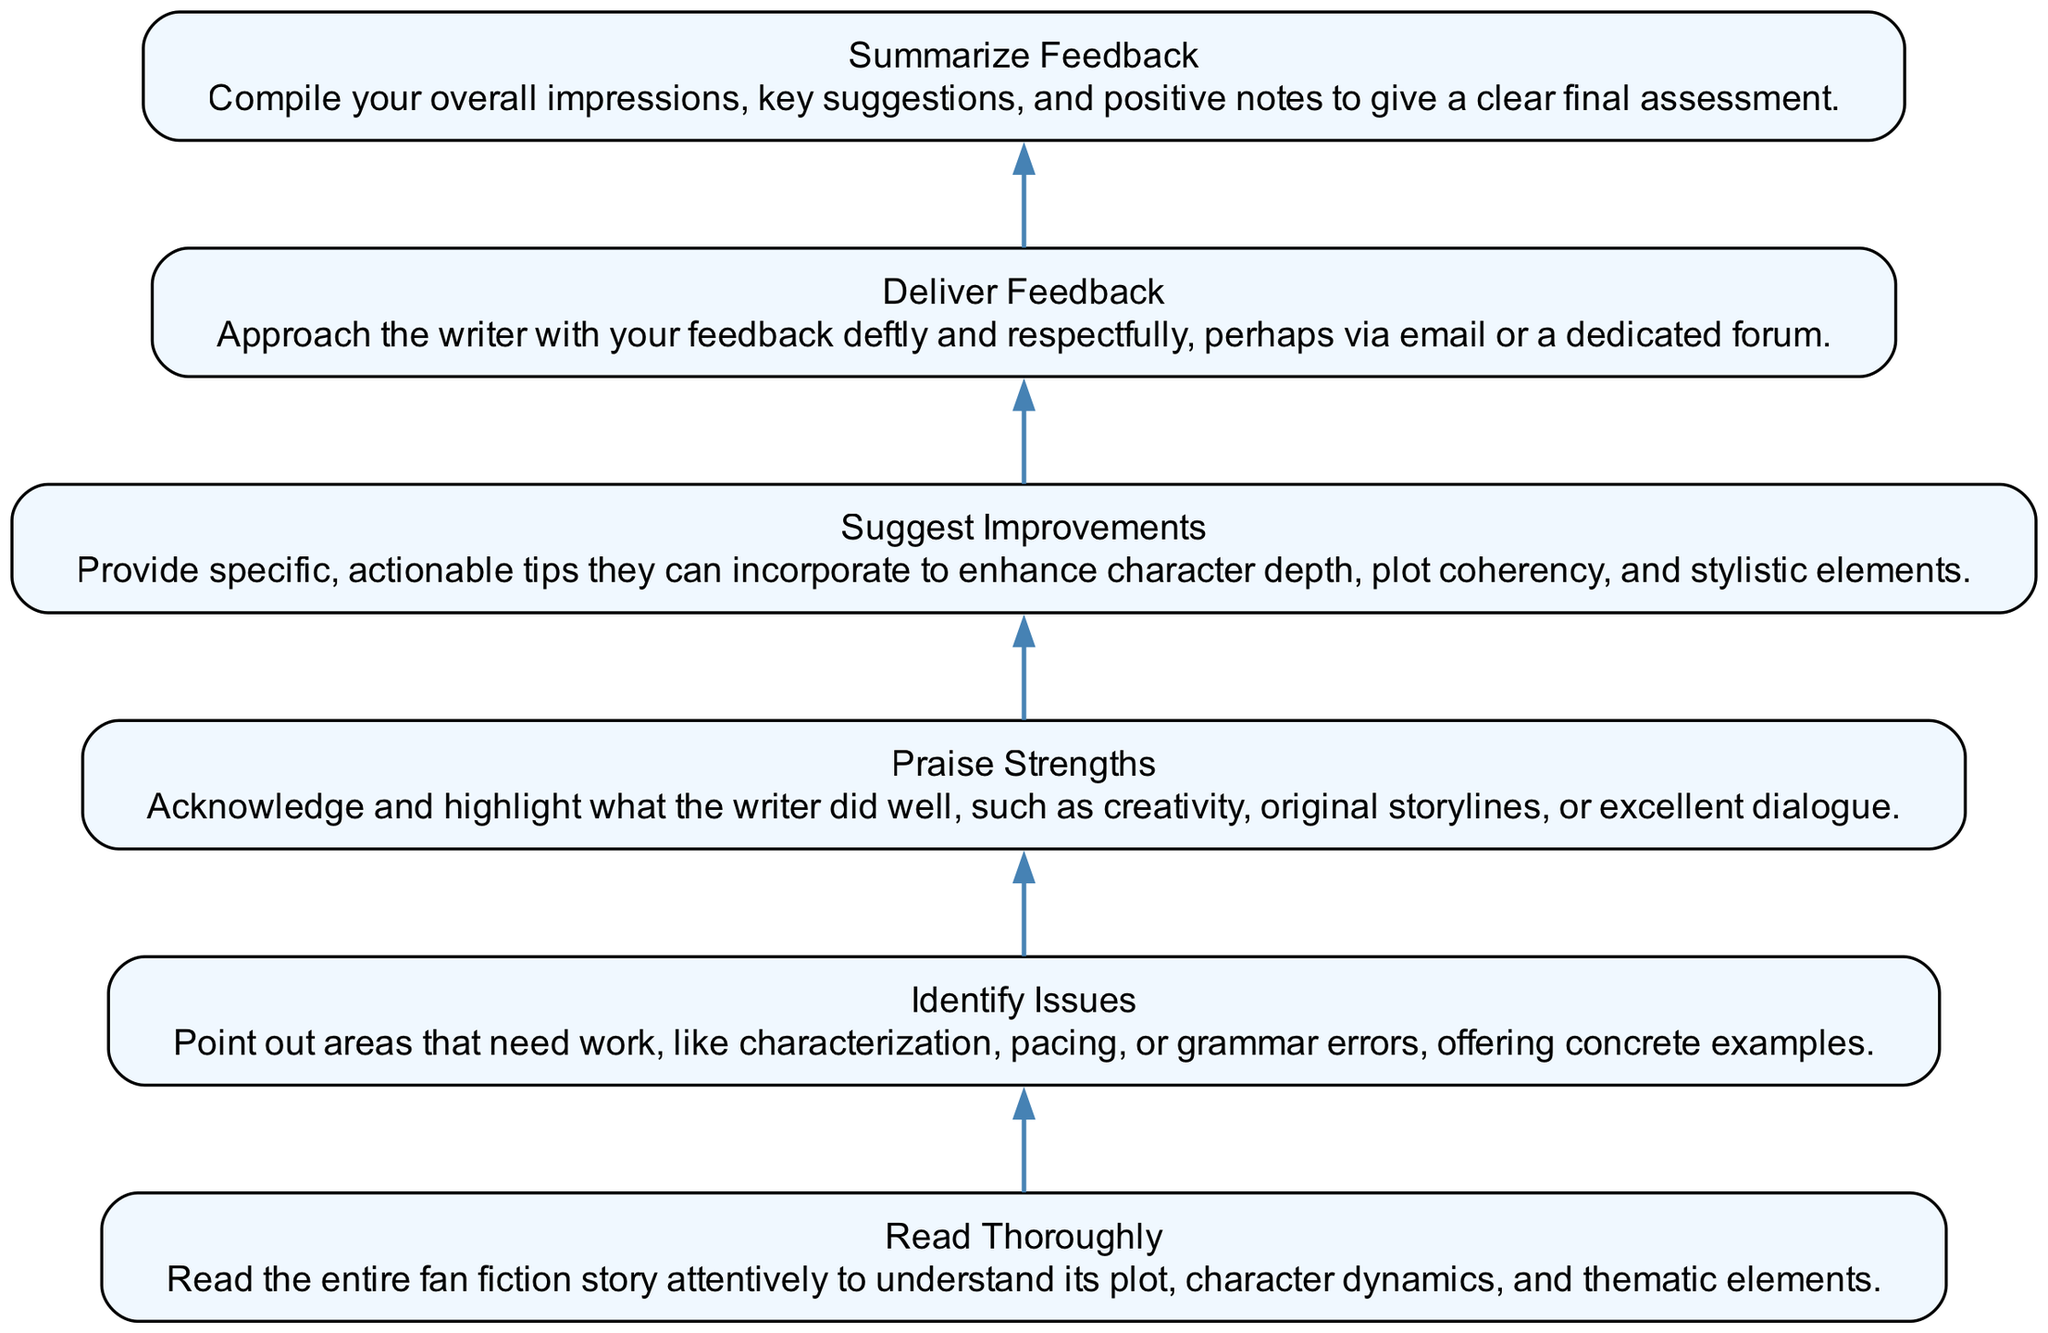What is the first step in the flowchart? The flowchart starts with the "Read Thoroughly" step, which instructs readers to engage with the entire text.
Answer: Read Thoroughly How many total steps are present in the flowchart? The diagram contains a total of six distinct steps related to constructive criticism on fan fiction stories.
Answer: Six Which step comes immediately after "Identify Issues"? The next step after "Identify Issues" is "Praise Strengths." This follows the identification of issues and leads to recognizing the positive aspects of the story.
Answer: Praise Strengths What is the last step in the feedback process? The final step of the process is "Summarize Feedback," which allows for a final assessment that includes key suggestions and positive notes.
Answer: Summarize Feedback How many nodes have "next" connections in the diagram? Out of the six steps, five of them have "next" connections that guide the flow of the feedback process, except for the last step, "Summarize Feedback."
Answer: Five Why is "Suggest Improvements" positioned before "Deliver Feedback"? "Suggest Improvements" logically precedes "Deliver Feedback" because actionable tips should be formulated prior to presenting them to the writer. It outlines the contributions before the final delivery.
Answer: Because it outlines contributions first Which two steps focus on strengths and weaknesses? The steps "Identify Issues" and "Praise Strengths" both address the critique’s dual nature: one highlights weaknesses while the other uplifts strengths, ensuring balanced feedback.
Answer: Identify Issues and Praise Strengths What element precedes "Identify Issues"? The step that comes before "Identify Issues" is "Read Thoroughly," emphasizing the importance of reading the entire story before pinpointing areas for improvement.
Answer: Read Thoroughly 